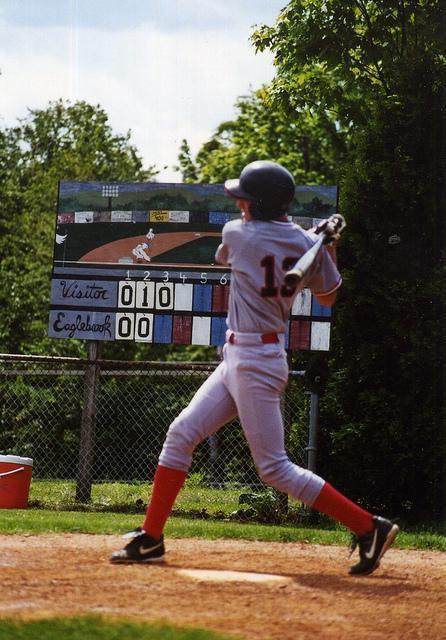How many posts does the sign have?
Give a very brief answer. 2. How many people are there?
Give a very brief answer. 2. 